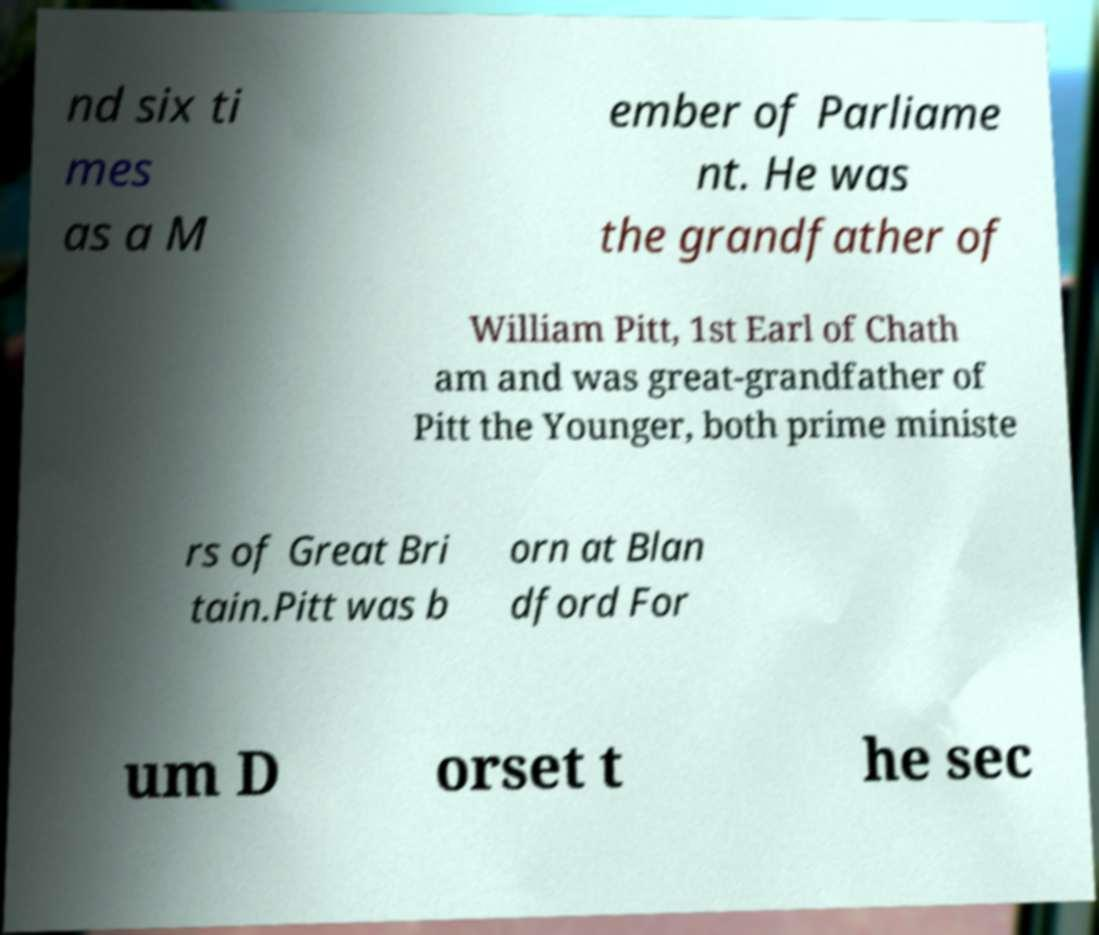Please identify and transcribe the text found in this image. nd six ti mes as a M ember of Parliame nt. He was the grandfather of William Pitt, 1st Earl of Chath am and was great-grandfather of Pitt the Younger, both prime ministe rs of Great Bri tain.Pitt was b orn at Blan dford For um D orset t he sec 